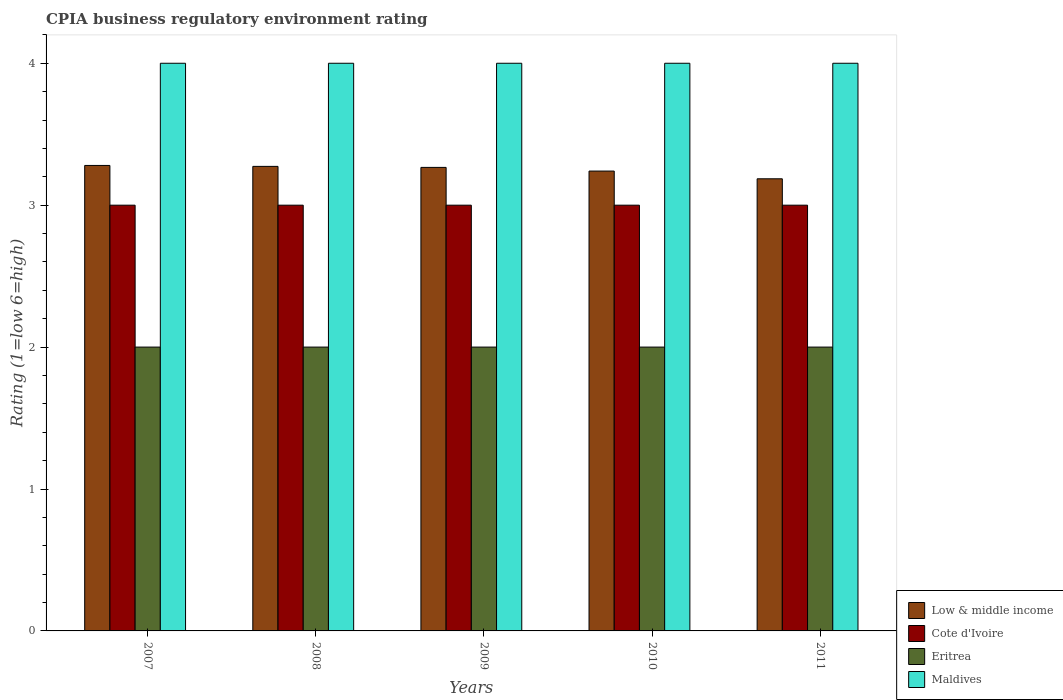How many groups of bars are there?
Offer a terse response. 5. Are the number of bars per tick equal to the number of legend labels?
Give a very brief answer. Yes. How many bars are there on the 4th tick from the left?
Provide a succinct answer. 4. How many bars are there on the 3rd tick from the right?
Your answer should be compact. 4. What is the label of the 3rd group of bars from the left?
Your answer should be compact. 2009. In how many cases, is the number of bars for a given year not equal to the number of legend labels?
Your answer should be compact. 0. What is the CPIA rating in Eritrea in 2010?
Ensure brevity in your answer.  2. Across all years, what is the maximum CPIA rating in Maldives?
Make the answer very short. 4. Across all years, what is the minimum CPIA rating in Cote d'Ivoire?
Your answer should be compact. 3. In which year was the CPIA rating in Cote d'Ivoire maximum?
Your answer should be very brief. 2007. In which year was the CPIA rating in Maldives minimum?
Make the answer very short. 2007. What is the total CPIA rating in Low & middle income in the graph?
Offer a very short reply. 16.25. In the year 2010, what is the difference between the CPIA rating in Cote d'Ivoire and CPIA rating in Maldives?
Keep it short and to the point. -1. What is the ratio of the CPIA rating in Low & middle income in 2008 to that in 2010?
Provide a succinct answer. 1.01. Is the CPIA rating in Low & middle income in 2007 less than that in 2011?
Keep it short and to the point. No. What is the difference between the highest and the second highest CPIA rating in Low & middle income?
Ensure brevity in your answer.  0.01. What is the difference between the highest and the lowest CPIA rating in Maldives?
Give a very brief answer. 0. What does the 1st bar from the left in 2008 represents?
Your response must be concise. Low & middle income. Is it the case that in every year, the sum of the CPIA rating in Low & middle income and CPIA rating in Maldives is greater than the CPIA rating in Cote d'Ivoire?
Provide a short and direct response. Yes. How many years are there in the graph?
Offer a very short reply. 5. Are the values on the major ticks of Y-axis written in scientific E-notation?
Ensure brevity in your answer.  No. Does the graph contain any zero values?
Make the answer very short. No. How are the legend labels stacked?
Keep it short and to the point. Vertical. What is the title of the graph?
Your answer should be compact. CPIA business regulatory environment rating. Does "Cyprus" appear as one of the legend labels in the graph?
Your answer should be very brief. No. What is the label or title of the X-axis?
Your answer should be compact. Years. What is the Rating (1=low 6=high) in Low & middle income in 2007?
Your answer should be very brief. 3.28. What is the Rating (1=low 6=high) in Cote d'Ivoire in 2007?
Give a very brief answer. 3. What is the Rating (1=low 6=high) of Low & middle income in 2008?
Ensure brevity in your answer.  3.27. What is the Rating (1=low 6=high) in Eritrea in 2008?
Offer a terse response. 2. What is the Rating (1=low 6=high) in Low & middle income in 2009?
Provide a succinct answer. 3.27. What is the Rating (1=low 6=high) of Cote d'Ivoire in 2009?
Provide a succinct answer. 3. What is the Rating (1=low 6=high) of Maldives in 2009?
Your response must be concise. 4. What is the Rating (1=low 6=high) of Low & middle income in 2010?
Provide a short and direct response. 3.24. What is the Rating (1=low 6=high) in Eritrea in 2010?
Your answer should be compact. 2. What is the Rating (1=low 6=high) of Low & middle income in 2011?
Give a very brief answer. 3.19. What is the Rating (1=low 6=high) in Eritrea in 2011?
Provide a short and direct response. 2. What is the Rating (1=low 6=high) in Maldives in 2011?
Give a very brief answer. 4. Across all years, what is the maximum Rating (1=low 6=high) of Low & middle income?
Offer a terse response. 3.28. Across all years, what is the minimum Rating (1=low 6=high) in Low & middle income?
Offer a terse response. 3.19. Across all years, what is the minimum Rating (1=low 6=high) of Eritrea?
Keep it short and to the point. 2. Across all years, what is the minimum Rating (1=low 6=high) in Maldives?
Give a very brief answer. 4. What is the total Rating (1=low 6=high) of Low & middle income in the graph?
Offer a very short reply. 16.25. What is the total Rating (1=low 6=high) of Cote d'Ivoire in the graph?
Provide a succinct answer. 15. What is the total Rating (1=low 6=high) of Eritrea in the graph?
Your answer should be compact. 10. What is the total Rating (1=low 6=high) of Maldives in the graph?
Your answer should be very brief. 20. What is the difference between the Rating (1=low 6=high) of Low & middle income in 2007 and that in 2008?
Your answer should be very brief. 0.01. What is the difference between the Rating (1=low 6=high) in Eritrea in 2007 and that in 2008?
Offer a very short reply. 0. What is the difference between the Rating (1=low 6=high) of Low & middle income in 2007 and that in 2009?
Ensure brevity in your answer.  0.01. What is the difference between the Rating (1=low 6=high) in Eritrea in 2007 and that in 2009?
Make the answer very short. 0. What is the difference between the Rating (1=low 6=high) of Low & middle income in 2007 and that in 2010?
Provide a succinct answer. 0.04. What is the difference between the Rating (1=low 6=high) in Cote d'Ivoire in 2007 and that in 2010?
Ensure brevity in your answer.  0. What is the difference between the Rating (1=low 6=high) in Maldives in 2007 and that in 2010?
Your answer should be compact. 0. What is the difference between the Rating (1=low 6=high) of Low & middle income in 2007 and that in 2011?
Offer a terse response. 0.09. What is the difference between the Rating (1=low 6=high) in Eritrea in 2007 and that in 2011?
Provide a short and direct response. 0. What is the difference between the Rating (1=low 6=high) of Maldives in 2007 and that in 2011?
Your answer should be very brief. 0. What is the difference between the Rating (1=low 6=high) of Low & middle income in 2008 and that in 2009?
Ensure brevity in your answer.  0.01. What is the difference between the Rating (1=low 6=high) in Cote d'Ivoire in 2008 and that in 2009?
Keep it short and to the point. 0. What is the difference between the Rating (1=low 6=high) in Eritrea in 2008 and that in 2009?
Your answer should be very brief. 0. What is the difference between the Rating (1=low 6=high) of Maldives in 2008 and that in 2009?
Give a very brief answer. 0. What is the difference between the Rating (1=low 6=high) in Low & middle income in 2008 and that in 2010?
Your response must be concise. 0.03. What is the difference between the Rating (1=low 6=high) in Maldives in 2008 and that in 2010?
Ensure brevity in your answer.  0. What is the difference between the Rating (1=low 6=high) of Low & middle income in 2008 and that in 2011?
Your response must be concise. 0.09. What is the difference between the Rating (1=low 6=high) of Cote d'Ivoire in 2008 and that in 2011?
Give a very brief answer. 0. What is the difference between the Rating (1=low 6=high) of Eritrea in 2008 and that in 2011?
Offer a terse response. 0. What is the difference between the Rating (1=low 6=high) in Low & middle income in 2009 and that in 2010?
Offer a terse response. 0.03. What is the difference between the Rating (1=low 6=high) of Low & middle income in 2009 and that in 2011?
Ensure brevity in your answer.  0.08. What is the difference between the Rating (1=low 6=high) of Low & middle income in 2010 and that in 2011?
Give a very brief answer. 0.05. What is the difference between the Rating (1=low 6=high) in Cote d'Ivoire in 2010 and that in 2011?
Your answer should be compact. 0. What is the difference between the Rating (1=low 6=high) of Maldives in 2010 and that in 2011?
Your response must be concise. 0. What is the difference between the Rating (1=low 6=high) in Low & middle income in 2007 and the Rating (1=low 6=high) in Cote d'Ivoire in 2008?
Your answer should be compact. 0.28. What is the difference between the Rating (1=low 6=high) in Low & middle income in 2007 and the Rating (1=low 6=high) in Eritrea in 2008?
Provide a short and direct response. 1.28. What is the difference between the Rating (1=low 6=high) of Low & middle income in 2007 and the Rating (1=low 6=high) of Maldives in 2008?
Provide a short and direct response. -0.72. What is the difference between the Rating (1=low 6=high) in Cote d'Ivoire in 2007 and the Rating (1=low 6=high) in Maldives in 2008?
Offer a very short reply. -1. What is the difference between the Rating (1=low 6=high) in Eritrea in 2007 and the Rating (1=low 6=high) in Maldives in 2008?
Provide a succinct answer. -2. What is the difference between the Rating (1=low 6=high) in Low & middle income in 2007 and the Rating (1=low 6=high) in Cote d'Ivoire in 2009?
Provide a succinct answer. 0.28. What is the difference between the Rating (1=low 6=high) of Low & middle income in 2007 and the Rating (1=low 6=high) of Eritrea in 2009?
Offer a very short reply. 1.28. What is the difference between the Rating (1=low 6=high) in Low & middle income in 2007 and the Rating (1=low 6=high) in Maldives in 2009?
Provide a short and direct response. -0.72. What is the difference between the Rating (1=low 6=high) in Cote d'Ivoire in 2007 and the Rating (1=low 6=high) in Eritrea in 2009?
Provide a succinct answer. 1. What is the difference between the Rating (1=low 6=high) in Eritrea in 2007 and the Rating (1=low 6=high) in Maldives in 2009?
Give a very brief answer. -2. What is the difference between the Rating (1=low 6=high) in Low & middle income in 2007 and the Rating (1=low 6=high) in Cote d'Ivoire in 2010?
Your answer should be compact. 0.28. What is the difference between the Rating (1=low 6=high) of Low & middle income in 2007 and the Rating (1=low 6=high) of Eritrea in 2010?
Offer a very short reply. 1.28. What is the difference between the Rating (1=low 6=high) in Low & middle income in 2007 and the Rating (1=low 6=high) in Maldives in 2010?
Provide a short and direct response. -0.72. What is the difference between the Rating (1=low 6=high) of Cote d'Ivoire in 2007 and the Rating (1=low 6=high) of Eritrea in 2010?
Provide a short and direct response. 1. What is the difference between the Rating (1=low 6=high) of Cote d'Ivoire in 2007 and the Rating (1=low 6=high) of Maldives in 2010?
Provide a short and direct response. -1. What is the difference between the Rating (1=low 6=high) in Eritrea in 2007 and the Rating (1=low 6=high) in Maldives in 2010?
Provide a succinct answer. -2. What is the difference between the Rating (1=low 6=high) of Low & middle income in 2007 and the Rating (1=low 6=high) of Cote d'Ivoire in 2011?
Provide a short and direct response. 0.28. What is the difference between the Rating (1=low 6=high) in Low & middle income in 2007 and the Rating (1=low 6=high) in Eritrea in 2011?
Provide a short and direct response. 1.28. What is the difference between the Rating (1=low 6=high) in Low & middle income in 2007 and the Rating (1=low 6=high) in Maldives in 2011?
Make the answer very short. -0.72. What is the difference between the Rating (1=low 6=high) of Cote d'Ivoire in 2007 and the Rating (1=low 6=high) of Maldives in 2011?
Give a very brief answer. -1. What is the difference between the Rating (1=low 6=high) in Eritrea in 2007 and the Rating (1=low 6=high) in Maldives in 2011?
Keep it short and to the point. -2. What is the difference between the Rating (1=low 6=high) of Low & middle income in 2008 and the Rating (1=low 6=high) of Cote d'Ivoire in 2009?
Ensure brevity in your answer.  0.27. What is the difference between the Rating (1=low 6=high) of Low & middle income in 2008 and the Rating (1=low 6=high) of Eritrea in 2009?
Provide a succinct answer. 1.27. What is the difference between the Rating (1=low 6=high) in Low & middle income in 2008 and the Rating (1=low 6=high) in Maldives in 2009?
Your answer should be very brief. -0.73. What is the difference between the Rating (1=low 6=high) in Cote d'Ivoire in 2008 and the Rating (1=low 6=high) in Maldives in 2009?
Your answer should be very brief. -1. What is the difference between the Rating (1=low 6=high) of Eritrea in 2008 and the Rating (1=low 6=high) of Maldives in 2009?
Your answer should be very brief. -2. What is the difference between the Rating (1=low 6=high) in Low & middle income in 2008 and the Rating (1=low 6=high) in Cote d'Ivoire in 2010?
Provide a succinct answer. 0.27. What is the difference between the Rating (1=low 6=high) of Low & middle income in 2008 and the Rating (1=low 6=high) of Eritrea in 2010?
Keep it short and to the point. 1.27. What is the difference between the Rating (1=low 6=high) in Low & middle income in 2008 and the Rating (1=low 6=high) in Maldives in 2010?
Give a very brief answer. -0.73. What is the difference between the Rating (1=low 6=high) of Cote d'Ivoire in 2008 and the Rating (1=low 6=high) of Maldives in 2010?
Make the answer very short. -1. What is the difference between the Rating (1=low 6=high) of Low & middle income in 2008 and the Rating (1=low 6=high) of Cote d'Ivoire in 2011?
Your answer should be very brief. 0.27. What is the difference between the Rating (1=low 6=high) in Low & middle income in 2008 and the Rating (1=low 6=high) in Eritrea in 2011?
Provide a short and direct response. 1.27. What is the difference between the Rating (1=low 6=high) in Low & middle income in 2008 and the Rating (1=low 6=high) in Maldives in 2011?
Your answer should be very brief. -0.73. What is the difference between the Rating (1=low 6=high) in Cote d'Ivoire in 2008 and the Rating (1=low 6=high) in Maldives in 2011?
Offer a terse response. -1. What is the difference between the Rating (1=low 6=high) of Eritrea in 2008 and the Rating (1=low 6=high) of Maldives in 2011?
Your answer should be very brief. -2. What is the difference between the Rating (1=low 6=high) of Low & middle income in 2009 and the Rating (1=low 6=high) of Cote d'Ivoire in 2010?
Offer a terse response. 0.27. What is the difference between the Rating (1=low 6=high) in Low & middle income in 2009 and the Rating (1=low 6=high) in Eritrea in 2010?
Make the answer very short. 1.27. What is the difference between the Rating (1=low 6=high) in Low & middle income in 2009 and the Rating (1=low 6=high) in Maldives in 2010?
Your answer should be compact. -0.73. What is the difference between the Rating (1=low 6=high) of Cote d'Ivoire in 2009 and the Rating (1=low 6=high) of Maldives in 2010?
Give a very brief answer. -1. What is the difference between the Rating (1=low 6=high) of Low & middle income in 2009 and the Rating (1=low 6=high) of Cote d'Ivoire in 2011?
Offer a terse response. 0.27. What is the difference between the Rating (1=low 6=high) of Low & middle income in 2009 and the Rating (1=low 6=high) of Eritrea in 2011?
Offer a very short reply. 1.27. What is the difference between the Rating (1=low 6=high) in Low & middle income in 2009 and the Rating (1=low 6=high) in Maldives in 2011?
Make the answer very short. -0.73. What is the difference between the Rating (1=low 6=high) in Eritrea in 2009 and the Rating (1=low 6=high) in Maldives in 2011?
Your response must be concise. -2. What is the difference between the Rating (1=low 6=high) in Low & middle income in 2010 and the Rating (1=low 6=high) in Cote d'Ivoire in 2011?
Offer a terse response. 0.24. What is the difference between the Rating (1=low 6=high) of Low & middle income in 2010 and the Rating (1=low 6=high) of Eritrea in 2011?
Make the answer very short. 1.24. What is the difference between the Rating (1=low 6=high) in Low & middle income in 2010 and the Rating (1=low 6=high) in Maldives in 2011?
Offer a terse response. -0.76. What is the difference between the Rating (1=low 6=high) of Cote d'Ivoire in 2010 and the Rating (1=low 6=high) of Maldives in 2011?
Offer a terse response. -1. What is the difference between the Rating (1=low 6=high) in Eritrea in 2010 and the Rating (1=low 6=high) in Maldives in 2011?
Your response must be concise. -2. What is the average Rating (1=low 6=high) of Low & middle income per year?
Ensure brevity in your answer.  3.25. What is the average Rating (1=low 6=high) in Cote d'Ivoire per year?
Make the answer very short. 3. In the year 2007, what is the difference between the Rating (1=low 6=high) in Low & middle income and Rating (1=low 6=high) in Cote d'Ivoire?
Make the answer very short. 0.28. In the year 2007, what is the difference between the Rating (1=low 6=high) of Low & middle income and Rating (1=low 6=high) of Eritrea?
Provide a succinct answer. 1.28. In the year 2007, what is the difference between the Rating (1=low 6=high) in Low & middle income and Rating (1=low 6=high) in Maldives?
Make the answer very short. -0.72. In the year 2007, what is the difference between the Rating (1=low 6=high) of Cote d'Ivoire and Rating (1=low 6=high) of Eritrea?
Ensure brevity in your answer.  1. In the year 2007, what is the difference between the Rating (1=low 6=high) of Cote d'Ivoire and Rating (1=low 6=high) of Maldives?
Your response must be concise. -1. In the year 2007, what is the difference between the Rating (1=low 6=high) of Eritrea and Rating (1=low 6=high) of Maldives?
Your answer should be very brief. -2. In the year 2008, what is the difference between the Rating (1=low 6=high) in Low & middle income and Rating (1=low 6=high) in Cote d'Ivoire?
Make the answer very short. 0.27. In the year 2008, what is the difference between the Rating (1=low 6=high) in Low & middle income and Rating (1=low 6=high) in Eritrea?
Your answer should be compact. 1.27. In the year 2008, what is the difference between the Rating (1=low 6=high) of Low & middle income and Rating (1=low 6=high) of Maldives?
Offer a terse response. -0.73. In the year 2008, what is the difference between the Rating (1=low 6=high) in Cote d'Ivoire and Rating (1=low 6=high) in Eritrea?
Offer a terse response. 1. In the year 2008, what is the difference between the Rating (1=low 6=high) of Eritrea and Rating (1=low 6=high) of Maldives?
Give a very brief answer. -2. In the year 2009, what is the difference between the Rating (1=low 6=high) of Low & middle income and Rating (1=low 6=high) of Cote d'Ivoire?
Your response must be concise. 0.27. In the year 2009, what is the difference between the Rating (1=low 6=high) in Low & middle income and Rating (1=low 6=high) in Eritrea?
Provide a short and direct response. 1.27. In the year 2009, what is the difference between the Rating (1=low 6=high) of Low & middle income and Rating (1=low 6=high) of Maldives?
Keep it short and to the point. -0.73. In the year 2009, what is the difference between the Rating (1=low 6=high) of Cote d'Ivoire and Rating (1=low 6=high) of Eritrea?
Provide a succinct answer. 1. In the year 2010, what is the difference between the Rating (1=low 6=high) in Low & middle income and Rating (1=low 6=high) in Cote d'Ivoire?
Offer a terse response. 0.24. In the year 2010, what is the difference between the Rating (1=low 6=high) of Low & middle income and Rating (1=low 6=high) of Eritrea?
Your response must be concise. 1.24. In the year 2010, what is the difference between the Rating (1=low 6=high) in Low & middle income and Rating (1=low 6=high) in Maldives?
Make the answer very short. -0.76. In the year 2010, what is the difference between the Rating (1=low 6=high) in Cote d'Ivoire and Rating (1=low 6=high) in Eritrea?
Your response must be concise. 1. In the year 2011, what is the difference between the Rating (1=low 6=high) in Low & middle income and Rating (1=low 6=high) in Cote d'Ivoire?
Offer a terse response. 0.19. In the year 2011, what is the difference between the Rating (1=low 6=high) in Low & middle income and Rating (1=low 6=high) in Eritrea?
Provide a succinct answer. 1.19. In the year 2011, what is the difference between the Rating (1=low 6=high) of Low & middle income and Rating (1=low 6=high) of Maldives?
Give a very brief answer. -0.81. In the year 2011, what is the difference between the Rating (1=low 6=high) in Cote d'Ivoire and Rating (1=low 6=high) in Eritrea?
Provide a short and direct response. 1. In the year 2011, what is the difference between the Rating (1=low 6=high) of Cote d'Ivoire and Rating (1=low 6=high) of Maldives?
Provide a short and direct response. -1. What is the ratio of the Rating (1=low 6=high) in Low & middle income in 2007 to that in 2008?
Your answer should be compact. 1. What is the ratio of the Rating (1=low 6=high) in Cote d'Ivoire in 2007 to that in 2008?
Keep it short and to the point. 1. What is the ratio of the Rating (1=low 6=high) in Cote d'Ivoire in 2007 to that in 2009?
Give a very brief answer. 1. What is the ratio of the Rating (1=low 6=high) in Maldives in 2007 to that in 2009?
Your response must be concise. 1. What is the ratio of the Rating (1=low 6=high) of Low & middle income in 2007 to that in 2010?
Offer a very short reply. 1.01. What is the ratio of the Rating (1=low 6=high) in Cote d'Ivoire in 2007 to that in 2010?
Keep it short and to the point. 1. What is the ratio of the Rating (1=low 6=high) of Eritrea in 2007 to that in 2010?
Make the answer very short. 1. What is the ratio of the Rating (1=low 6=high) of Low & middle income in 2007 to that in 2011?
Ensure brevity in your answer.  1.03. What is the ratio of the Rating (1=low 6=high) in Cote d'Ivoire in 2007 to that in 2011?
Keep it short and to the point. 1. What is the ratio of the Rating (1=low 6=high) of Eritrea in 2007 to that in 2011?
Your response must be concise. 1. What is the ratio of the Rating (1=low 6=high) in Low & middle income in 2008 to that in 2009?
Provide a succinct answer. 1. What is the ratio of the Rating (1=low 6=high) of Cote d'Ivoire in 2008 to that in 2009?
Your response must be concise. 1. What is the ratio of the Rating (1=low 6=high) in Maldives in 2008 to that in 2009?
Give a very brief answer. 1. What is the ratio of the Rating (1=low 6=high) of Low & middle income in 2008 to that in 2010?
Make the answer very short. 1.01. What is the ratio of the Rating (1=low 6=high) of Low & middle income in 2008 to that in 2011?
Make the answer very short. 1.03. What is the ratio of the Rating (1=low 6=high) of Cote d'Ivoire in 2008 to that in 2011?
Your answer should be compact. 1. What is the ratio of the Rating (1=low 6=high) of Eritrea in 2008 to that in 2011?
Your answer should be very brief. 1. What is the ratio of the Rating (1=low 6=high) in Maldives in 2009 to that in 2010?
Your response must be concise. 1. What is the ratio of the Rating (1=low 6=high) in Low & middle income in 2009 to that in 2011?
Keep it short and to the point. 1.03. What is the ratio of the Rating (1=low 6=high) in Cote d'Ivoire in 2009 to that in 2011?
Offer a very short reply. 1. What is the ratio of the Rating (1=low 6=high) in Eritrea in 2009 to that in 2011?
Provide a short and direct response. 1. What is the ratio of the Rating (1=low 6=high) in Maldives in 2009 to that in 2011?
Your response must be concise. 1. What is the ratio of the Rating (1=low 6=high) in Low & middle income in 2010 to that in 2011?
Make the answer very short. 1.02. What is the ratio of the Rating (1=low 6=high) in Cote d'Ivoire in 2010 to that in 2011?
Provide a succinct answer. 1. What is the ratio of the Rating (1=low 6=high) of Maldives in 2010 to that in 2011?
Your answer should be compact. 1. What is the difference between the highest and the second highest Rating (1=low 6=high) in Low & middle income?
Your answer should be compact. 0.01. What is the difference between the highest and the second highest Rating (1=low 6=high) of Maldives?
Provide a succinct answer. 0. What is the difference between the highest and the lowest Rating (1=low 6=high) of Low & middle income?
Give a very brief answer. 0.09. What is the difference between the highest and the lowest Rating (1=low 6=high) in Cote d'Ivoire?
Your response must be concise. 0. 